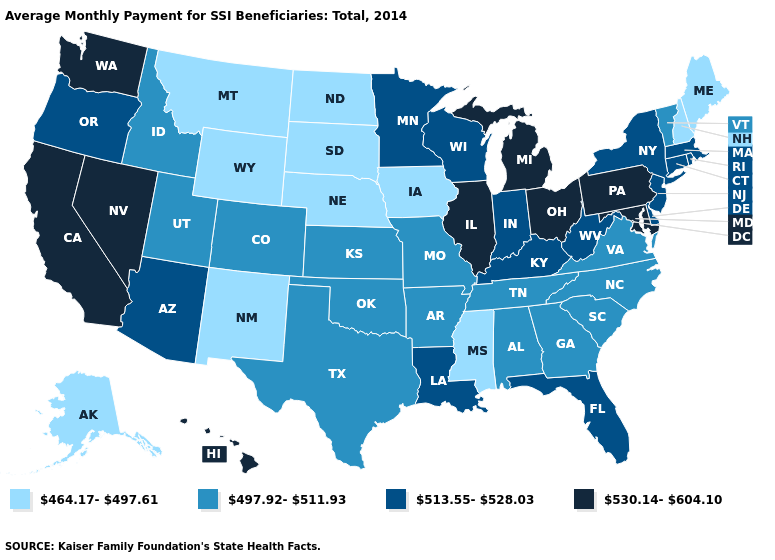Among the states that border Kentucky , which have the highest value?
Short answer required. Illinois, Ohio. What is the value of Wisconsin?
Keep it brief. 513.55-528.03. Among the states that border South Carolina , which have the lowest value?
Answer briefly. Georgia, North Carolina. What is the lowest value in the MidWest?
Short answer required. 464.17-497.61. Does the first symbol in the legend represent the smallest category?
Be succinct. Yes. Which states have the lowest value in the South?
Be succinct. Mississippi. Does the first symbol in the legend represent the smallest category?
Answer briefly. Yes. How many symbols are there in the legend?
Short answer required. 4. What is the value of New Hampshire?
Keep it brief. 464.17-497.61. Which states have the lowest value in the Northeast?
Be succinct. Maine, New Hampshire. Among the states that border Pennsylvania , does West Virginia have the highest value?
Short answer required. No. Name the states that have a value in the range 497.92-511.93?
Give a very brief answer. Alabama, Arkansas, Colorado, Georgia, Idaho, Kansas, Missouri, North Carolina, Oklahoma, South Carolina, Tennessee, Texas, Utah, Vermont, Virginia. What is the lowest value in states that border Iowa?
Keep it brief. 464.17-497.61. What is the value of Wisconsin?
Write a very short answer. 513.55-528.03. 